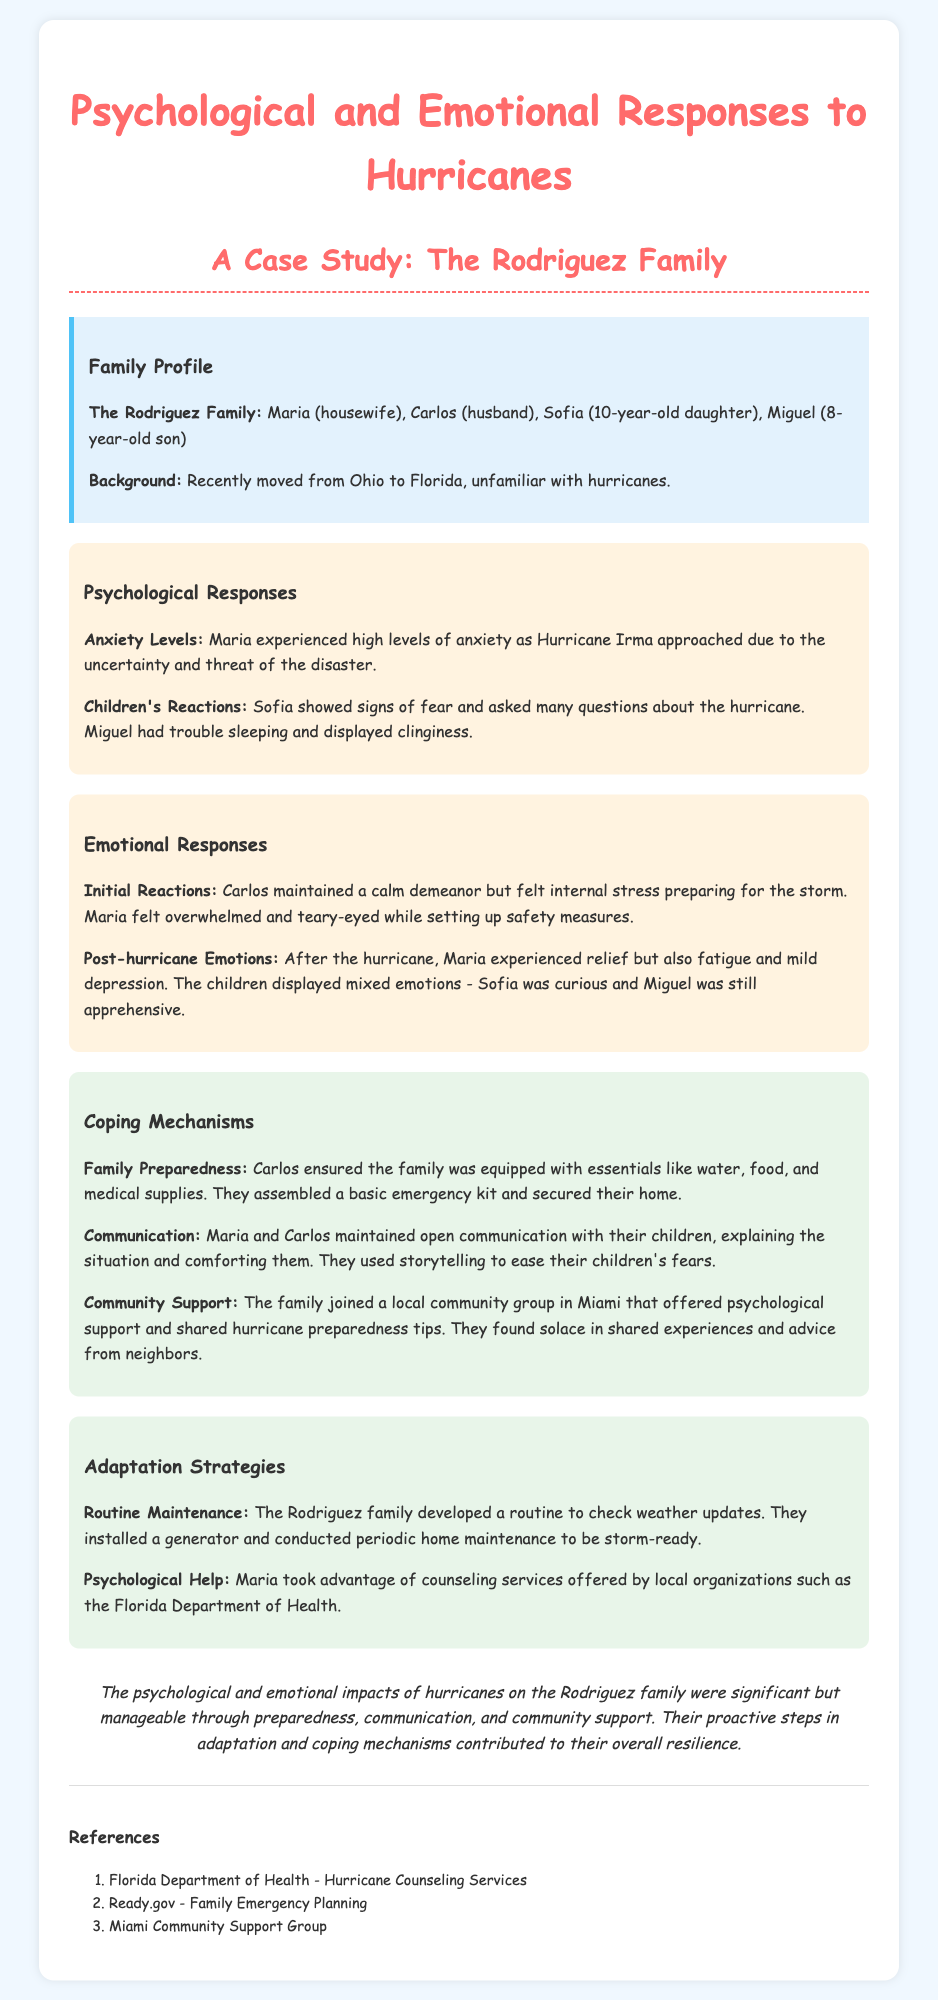What is the name of the family in the case study? The document introduces the family as the Rodriguez Family.
Answer: Rodriguez Family How many children do the Rodriguez family have? The family consists of two children: Sofia and Miguel.
Answer: Two What was Maria's emotional response while preparing for the storm? The document states that Maria felt overwhelmed and teary-eyed while setting up safety measures.
Answer: Overwhelmed and teary-eyed What coping mechanism did the Rodriguez family use for family preparedness? Carlos ensured the family was equipped with essentials like water, food, and medical supplies.
Answer: Ensured essentials What community support did the Rodriguez family join? They joined a local community group in Miami that offered psychological support and shared hurricane preparedness tips.
Answer: Local community group in Miami What was Sofia's reaction to the hurricane? Sofia showed signs of fear and asked many questions about the hurricane.
Answer: Fear and questions What strategy did the Rodriguez family maintain regarding weather updates? They developed a routine to check weather updates.
Answer: Routine to check weather updates Which organization provided María with counseling services? The document mentions the Florida Department of Health as offering counseling services.
Answer: Florida Department of Health 